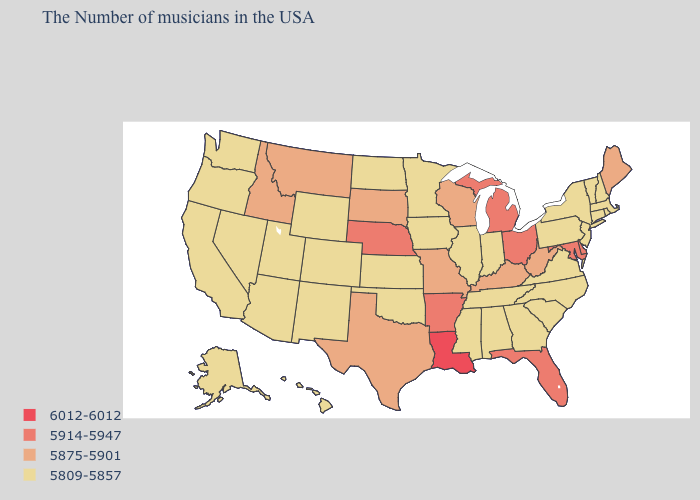Which states have the lowest value in the South?
Short answer required. Virginia, North Carolina, South Carolina, Georgia, Alabama, Tennessee, Mississippi, Oklahoma. Which states have the highest value in the USA?
Quick response, please. Louisiana. Among the states that border Wisconsin , which have the lowest value?
Give a very brief answer. Illinois, Minnesota, Iowa. Does Delaware have the same value as Maryland?
Be succinct. Yes. Name the states that have a value in the range 5914-5947?
Keep it brief. Delaware, Maryland, Ohio, Florida, Michigan, Arkansas, Nebraska. Which states hav the highest value in the West?
Short answer required. Montana, Idaho. Name the states that have a value in the range 5809-5857?
Write a very short answer. Massachusetts, Rhode Island, New Hampshire, Vermont, Connecticut, New York, New Jersey, Pennsylvania, Virginia, North Carolina, South Carolina, Georgia, Indiana, Alabama, Tennessee, Illinois, Mississippi, Minnesota, Iowa, Kansas, Oklahoma, North Dakota, Wyoming, Colorado, New Mexico, Utah, Arizona, Nevada, California, Washington, Oregon, Alaska, Hawaii. What is the highest value in the MidWest ?
Be succinct. 5914-5947. Does Maine have a lower value than Louisiana?
Quick response, please. Yes. What is the value of Kansas?
Give a very brief answer. 5809-5857. What is the lowest value in the South?
Be succinct. 5809-5857. How many symbols are there in the legend?
Answer briefly. 4. Does Louisiana have the highest value in the USA?
Write a very short answer. Yes. 